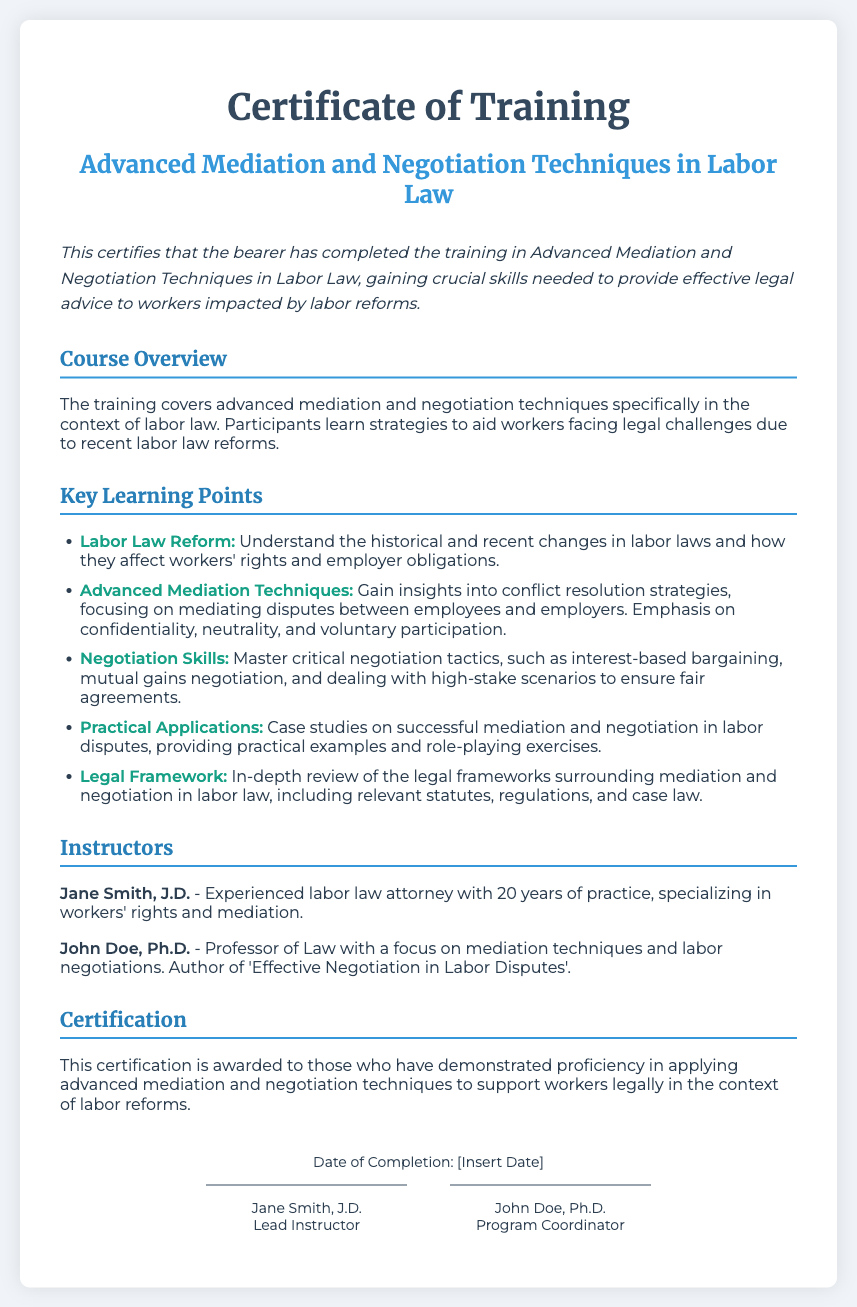What is the title of the training? The title is displayed prominently at the beginning of the document and specifies the focus of the training.
Answer: Advanced Mediation and Negotiation Techniques in Labor Law Who are the instructors for the training? The document lists the names and qualifications of the instructors involved in the training.
Answer: Jane Smith, J.D. and John Doe, Ph.D What is the summary of the certification? The summary provides a brief overview of what the certificate signifies about the holder’s training completion.
Answer: This certifies that the bearer has completed the training in Advanced Mediation and Negotiation Techniques in Labor Law How many key learning points are listed? The number of key learning points can be counted in the section dedicated to learning objectives.
Answer: Five What is the main focus of the course outlined in the course overview? The course overview explains the primary subject matter covered during the training.
Answer: Advanced mediation and negotiation techniques specifically in the context of labor law What is the date of completion placeholder in the document? The document indicates a placeholder for the date on which the training was completed.
Answer: [Insert Date] 